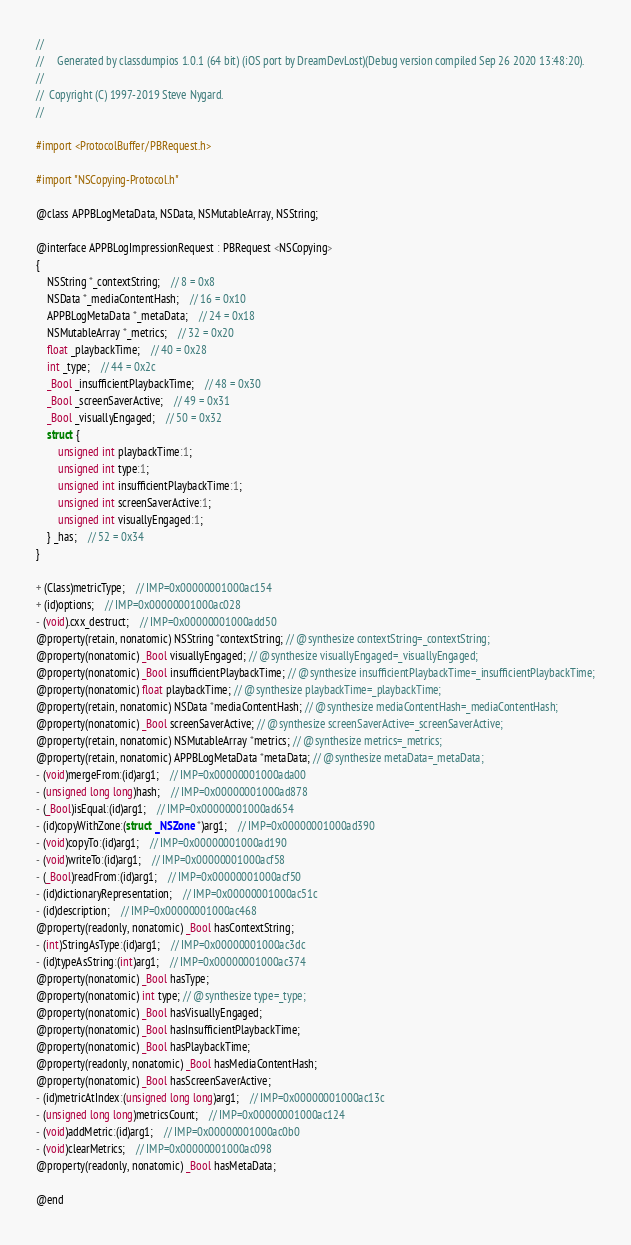<code> <loc_0><loc_0><loc_500><loc_500><_C_>//
//     Generated by classdumpios 1.0.1 (64 bit) (iOS port by DreamDevLost)(Debug version compiled Sep 26 2020 13:48:20).
//
//  Copyright (C) 1997-2019 Steve Nygard.
//

#import <ProtocolBuffer/PBRequest.h>

#import "NSCopying-Protocol.h"

@class APPBLogMetaData, NSData, NSMutableArray, NSString;

@interface APPBLogImpressionRequest : PBRequest <NSCopying>
{
    NSString *_contextString;	// 8 = 0x8
    NSData *_mediaContentHash;	// 16 = 0x10
    APPBLogMetaData *_metaData;	// 24 = 0x18
    NSMutableArray *_metrics;	// 32 = 0x20
    float _playbackTime;	// 40 = 0x28
    int _type;	// 44 = 0x2c
    _Bool _insufficientPlaybackTime;	// 48 = 0x30
    _Bool _screenSaverActive;	// 49 = 0x31
    _Bool _visuallyEngaged;	// 50 = 0x32
    struct {
        unsigned int playbackTime:1;
        unsigned int type:1;
        unsigned int insufficientPlaybackTime:1;
        unsigned int screenSaverActive:1;
        unsigned int visuallyEngaged:1;
    } _has;	// 52 = 0x34
}

+ (Class)metricType;	// IMP=0x00000001000ac154
+ (id)options;	// IMP=0x00000001000ac028
- (void).cxx_destruct;	// IMP=0x00000001000add50
@property(retain, nonatomic) NSString *contextString; // @synthesize contextString=_contextString;
@property(nonatomic) _Bool visuallyEngaged; // @synthesize visuallyEngaged=_visuallyEngaged;
@property(nonatomic) _Bool insufficientPlaybackTime; // @synthesize insufficientPlaybackTime=_insufficientPlaybackTime;
@property(nonatomic) float playbackTime; // @synthesize playbackTime=_playbackTime;
@property(retain, nonatomic) NSData *mediaContentHash; // @synthesize mediaContentHash=_mediaContentHash;
@property(nonatomic) _Bool screenSaverActive; // @synthesize screenSaverActive=_screenSaverActive;
@property(retain, nonatomic) NSMutableArray *metrics; // @synthesize metrics=_metrics;
@property(retain, nonatomic) APPBLogMetaData *metaData; // @synthesize metaData=_metaData;
- (void)mergeFrom:(id)arg1;	// IMP=0x00000001000ada00
- (unsigned long long)hash;	// IMP=0x00000001000ad878
- (_Bool)isEqual:(id)arg1;	// IMP=0x00000001000ad654
- (id)copyWithZone:(struct _NSZone *)arg1;	// IMP=0x00000001000ad390
- (void)copyTo:(id)arg1;	// IMP=0x00000001000ad190
- (void)writeTo:(id)arg1;	// IMP=0x00000001000acf58
- (_Bool)readFrom:(id)arg1;	// IMP=0x00000001000acf50
- (id)dictionaryRepresentation;	// IMP=0x00000001000ac51c
- (id)description;	// IMP=0x00000001000ac468
@property(readonly, nonatomic) _Bool hasContextString;
- (int)StringAsType:(id)arg1;	// IMP=0x00000001000ac3dc
- (id)typeAsString:(int)arg1;	// IMP=0x00000001000ac374
@property(nonatomic) _Bool hasType;
@property(nonatomic) int type; // @synthesize type=_type;
@property(nonatomic) _Bool hasVisuallyEngaged;
@property(nonatomic) _Bool hasInsufficientPlaybackTime;
@property(nonatomic) _Bool hasPlaybackTime;
@property(readonly, nonatomic) _Bool hasMediaContentHash;
@property(nonatomic) _Bool hasScreenSaverActive;
- (id)metricAtIndex:(unsigned long long)arg1;	// IMP=0x00000001000ac13c
- (unsigned long long)metricsCount;	// IMP=0x00000001000ac124
- (void)addMetric:(id)arg1;	// IMP=0x00000001000ac0b0
- (void)clearMetrics;	// IMP=0x00000001000ac098
@property(readonly, nonatomic) _Bool hasMetaData;

@end

</code> 